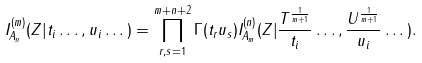Convert formula to latex. <formula><loc_0><loc_0><loc_500><loc_500>I ^ { ( m ) } _ { A _ { n } } ( Z | t _ { i } \dots , u _ { i } \dots ) = \prod _ { r , s = 1 } ^ { m + n + 2 } \Gamma ( t _ { r } u _ { s } ) I ^ { ( n ) } _ { A _ { m } } ( Z | \frac { T ^ { \frac { 1 } { m + 1 } } } { t _ { i } } \dots , \frac { U ^ { \frac { 1 } { m + 1 } } } { u _ { i } } \dots ) .</formula> 